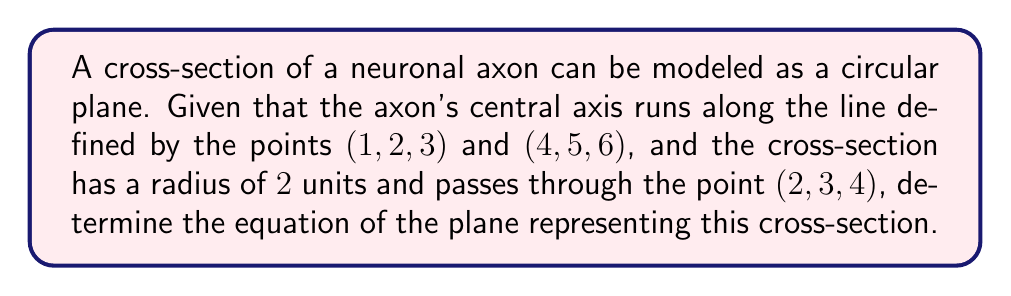Can you solve this math problem? Let's approach this step-by-step:

1) First, we need to find the direction vector of the axon's central axis. We can do this by subtracting the coordinates of the two given points:
   $\vec{v} = (4-1, 5-2, 6-3) = (3, 3, 3)$

2) This vector $\vec{v}$ is normal to our plane. We can normalize it:
   $\vec{n} = \frac{\vec{v}}{|\vec{v}|} = \frac{(3, 3, 3)}{\sqrt{3^2 + 3^2 + 3^2}} = (\frac{1}{\sqrt{3}}, \frac{1}{\sqrt{3}}, \frac{1}{\sqrt{3}})$

3) The general equation of a plane is $ax + by + cz + d = 0$, where $(a, b, c)$ is the normal vector.

4) Substituting our normal vector:
   $\frac{1}{\sqrt{3}}x + \frac{1}{\sqrt{3}}y + \frac{1}{\sqrt{3}}z + d = 0$

5) We can use the point (2, 3, 4) that lies on the plane to find $d$:
   $\frac{1}{\sqrt{3}}(2) + \frac{1}{\sqrt{3}}(3) + \frac{1}{\sqrt{3}}(4) + d = 0$
   $\frac{9}{\sqrt{3}} + d = 0$
   $d = -\frac{9}{\sqrt{3}}$

6) Therefore, the equation of the plane is:
   $\frac{1}{\sqrt{3}}x + \frac{1}{\sqrt{3}}y + \frac{1}{\sqrt{3}}z - \frac{9}{\sqrt{3}} = 0$

7) We can simplify this by multiplying everything by $\sqrt{3}$:
   $x + y + z - 9 = 0$
Answer: $x + y + z - 9 = 0$ 